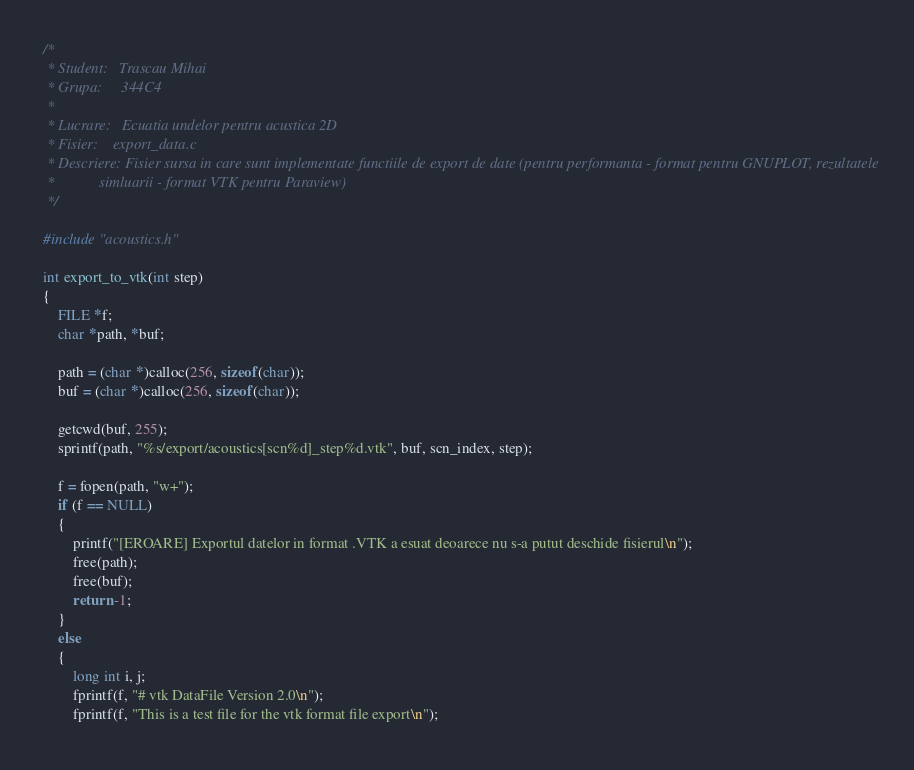<code> <loc_0><loc_0><loc_500><loc_500><_Cuda_>/*
 * Student:   Trascau Mihai
 * Grupa:     344C4
 * 
 * Lucrare:   Ecuatia undelor pentru acustica 2D
 * Fisier:    export_data.c
 * Descriere: Fisier sursa in care sunt implementate functiile de export de date (pentru performanta - format pentru GNUPLOT, rezultatele
 *            simluarii - format VTK pentru Paraview)
 */

#include "acoustics.h"

int export_to_vtk(int step)
{
    FILE *f;
    char *path, *buf;

    path = (char *)calloc(256, sizeof(char));
    buf = (char *)calloc(256, sizeof(char));

    getcwd(buf, 255);
    sprintf(path, "%s/export/acoustics[scn%d]_step%d.vtk", buf, scn_index, step);

    f = fopen(path, "w+");
    if (f == NULL)
    {
        printf("[EROARE] Exportul datelor in format .VTK a esuat deoarece nu s-a putut deschide fisierul\n");
        free(path);
        free(buf);
        return -1;
    }
    else
    {
        long int i, j;
        fprintf(f, "# vtk DataFile Version 2.0\n");
        fprintf(f, "This is a test file for the vtk format file export\n");</code> 